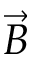Convert formula to latex. <formula><loc_0><loc_0><loc_500><loc_500>\vec { B }</formula> 